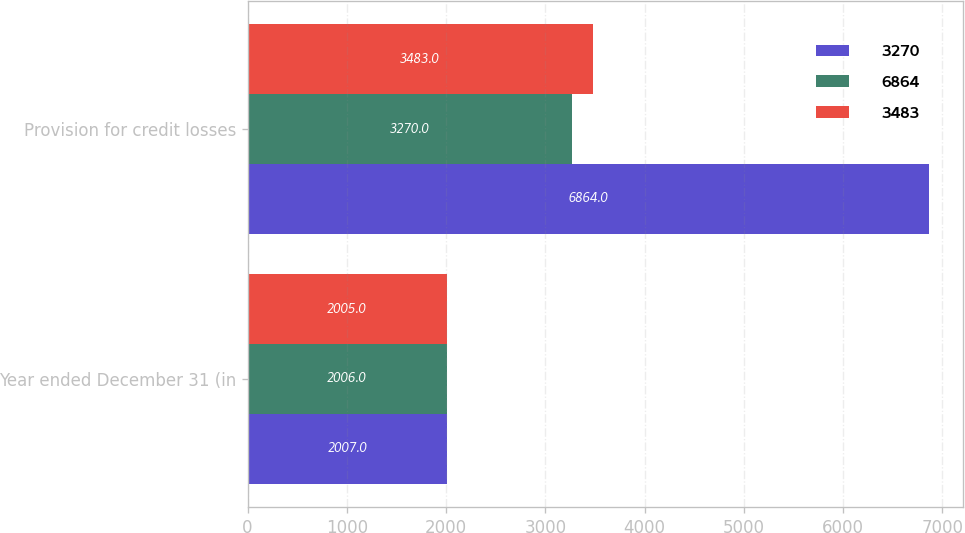Convert chart to OTSL. <chart><loc_0><loc_0><loc_500><loc_500><stacked_bar_chart><ecel><fcel>Year ended December 31 (in<fcel>Provision for credit losses<nl><fcel>3270<fcel>2007<fcel>6864<nl><fcel>6864<fcel>2006<fcel>3270<nl><fcel>3483<fcel>2005<fcel>3483<nl></chart> 